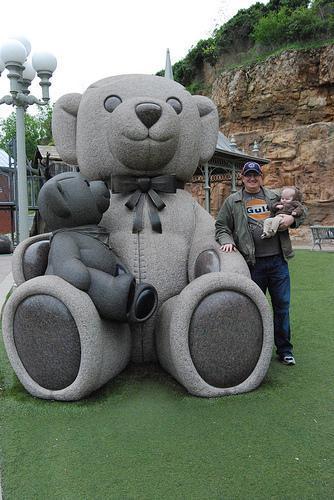How many babies are in the picture?
Give a very brief answer. 1. How many bears are in the picture?
Give a very brief answer. 2. 